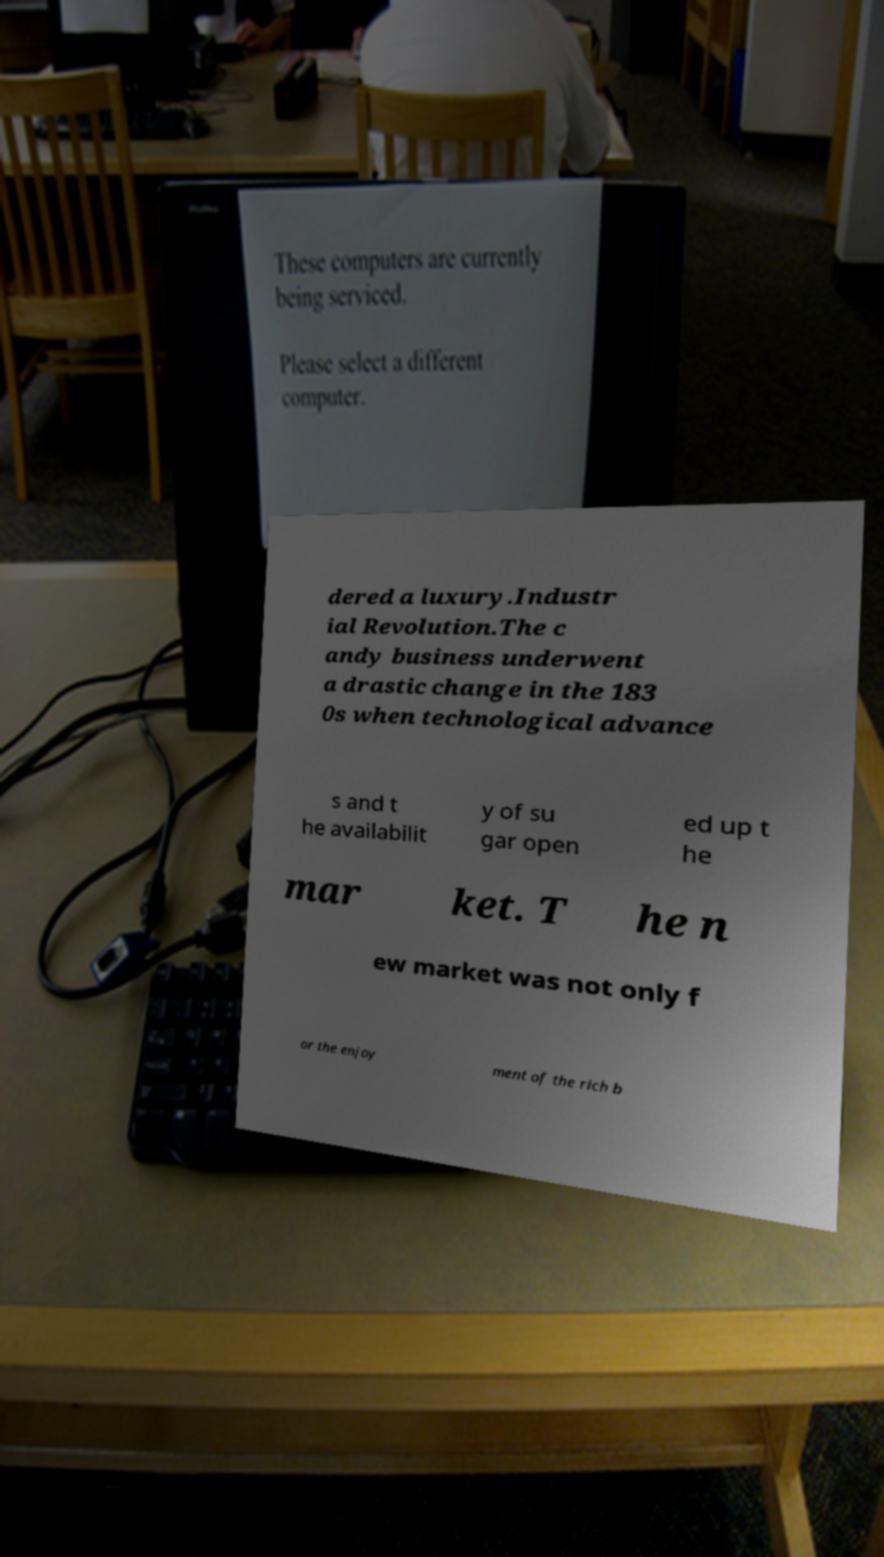What messages or text are displayed in this image? I need them in a readable, typed format. dered a luxury.Industr ial Revolution.The c andy business underwent a drastic change in the 183 0s when technological advance s and t he availabilit y of su gar open ed up t he mar ket. T he n ew market was not only f or the enjoy ment of the rich b 